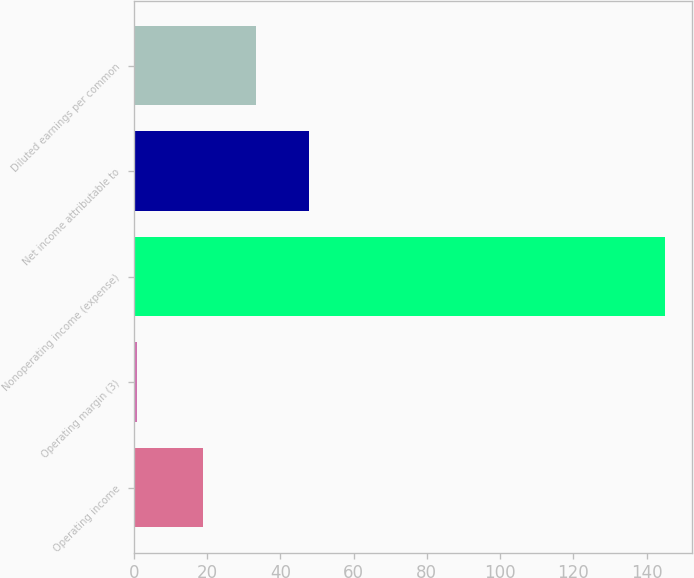Convert chart. <chart><loc_0><loc_0><loc_500><loc_500><bar_chart><fcel>Operating income<fcel>Operating margin (3)<fcel>Nonoperating income (expense)<fcel>Net income attributable to<fcel>Diluted earnings per common<nl><fcel>19<fcel>1<fcel>145<fcel>47.8<fcel>33.4<nl></chart> 